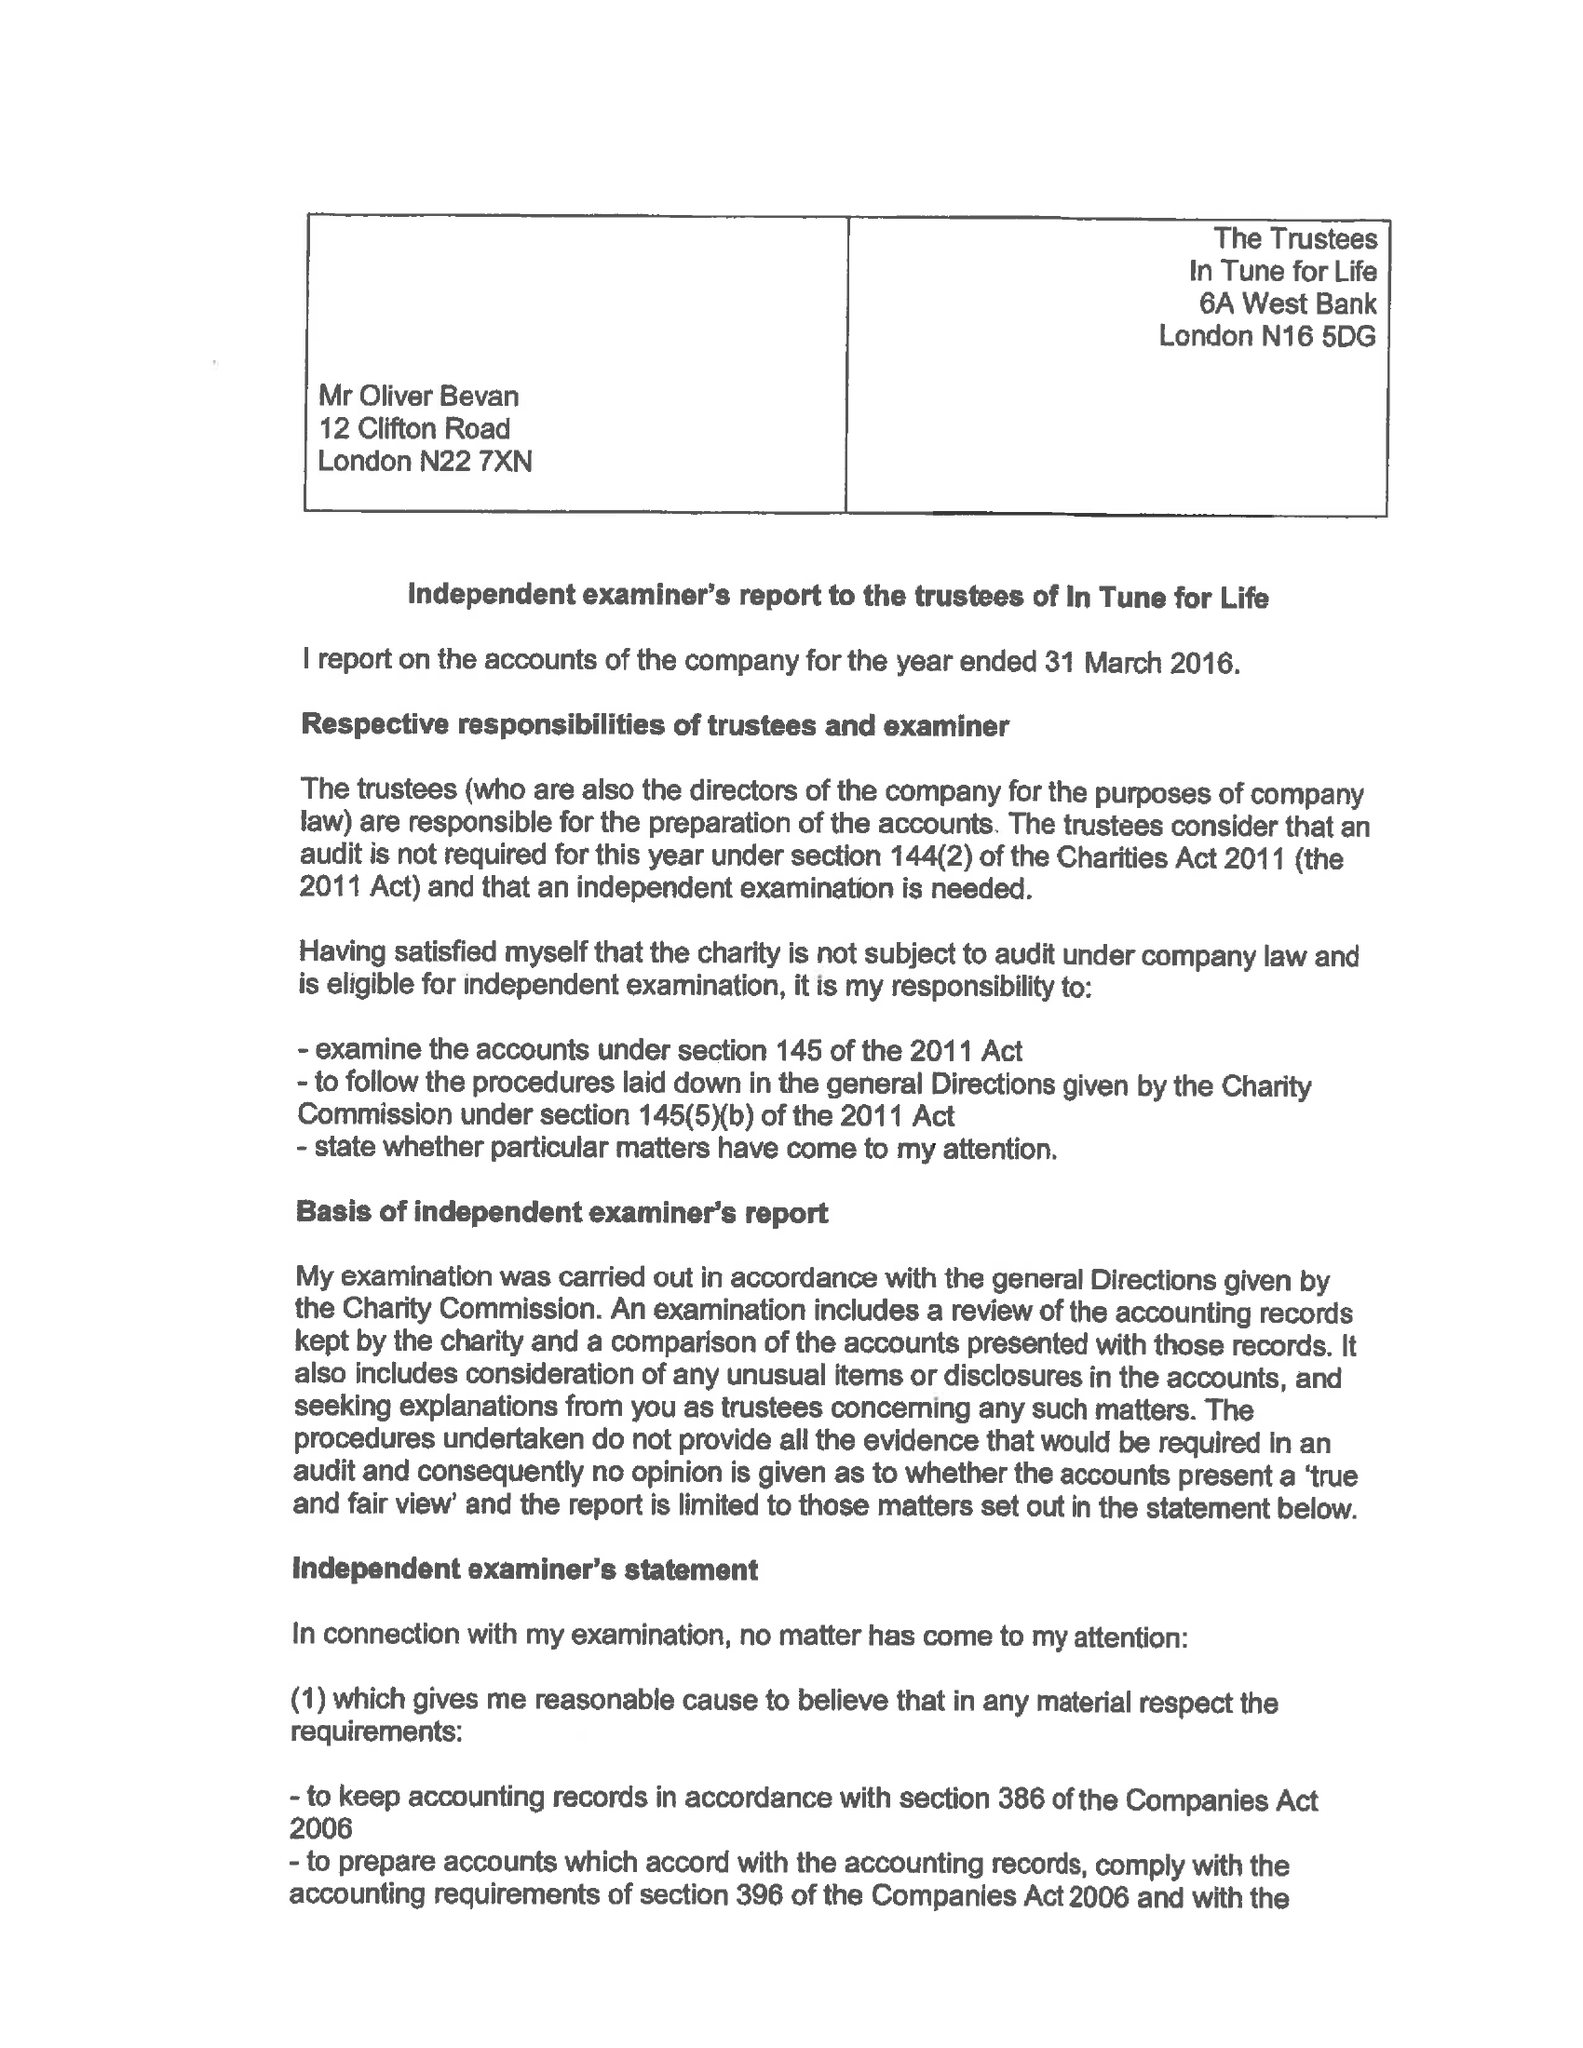What is the value for the income_annually_in_british_pounds?
Answer the question using a single word or phrase. 38998.00 